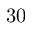Convert formula to latex. <formula><loc_0><loc_0><loc_500><loc_500>3 0</formula> 